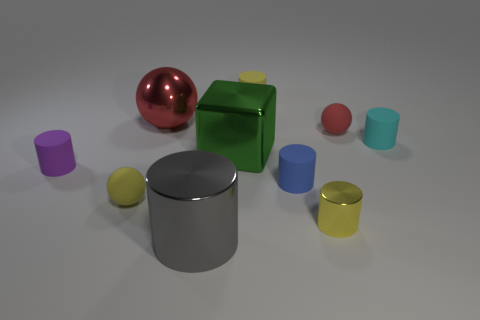There is a red ball that is the same size as the blue cylinder; what is its material?
Your answer should be compact. Rubber. Are the yellow cylinder that is behind the shiny sphere and the big thing that is behind the cyan rubber cylinder made of the same material?
Offer a very short reply. No. What is the shape of the blue object that is the same size as the yellow metal cylinder?
Your answer should be very brief. Cylinder. What number of other objects are there of the same color as the large shiny sphere?
Make the answer very short. 1. The small ball that is to the left of the yellow matte cylinder is what color?
Offer a very short reply. Yellow. How many other things are there of the same material as the small yellow ball?
Offer a terse response. 5. Are there more yellow rubber things to the right of the tiny yellow ball than metallic cylinders to the left of the metal ball?
Your answer should be very brief. Yes. What number of matte cylinders are left of the yellow rubber cylinder?
Offer a terse response. 1. Is the material of the tiny red ball the same as the yellow cylinder that is in front of the purple cylinder?
Offer a terse response. No. Is there anything else that is the same shape as the green metallic thing?
Offer a terse response. No. 